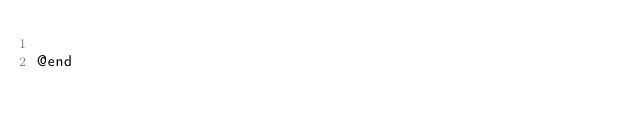<code> <loc_0><loc_0><loc_500><loc_500><_C_>
@end
</code> 